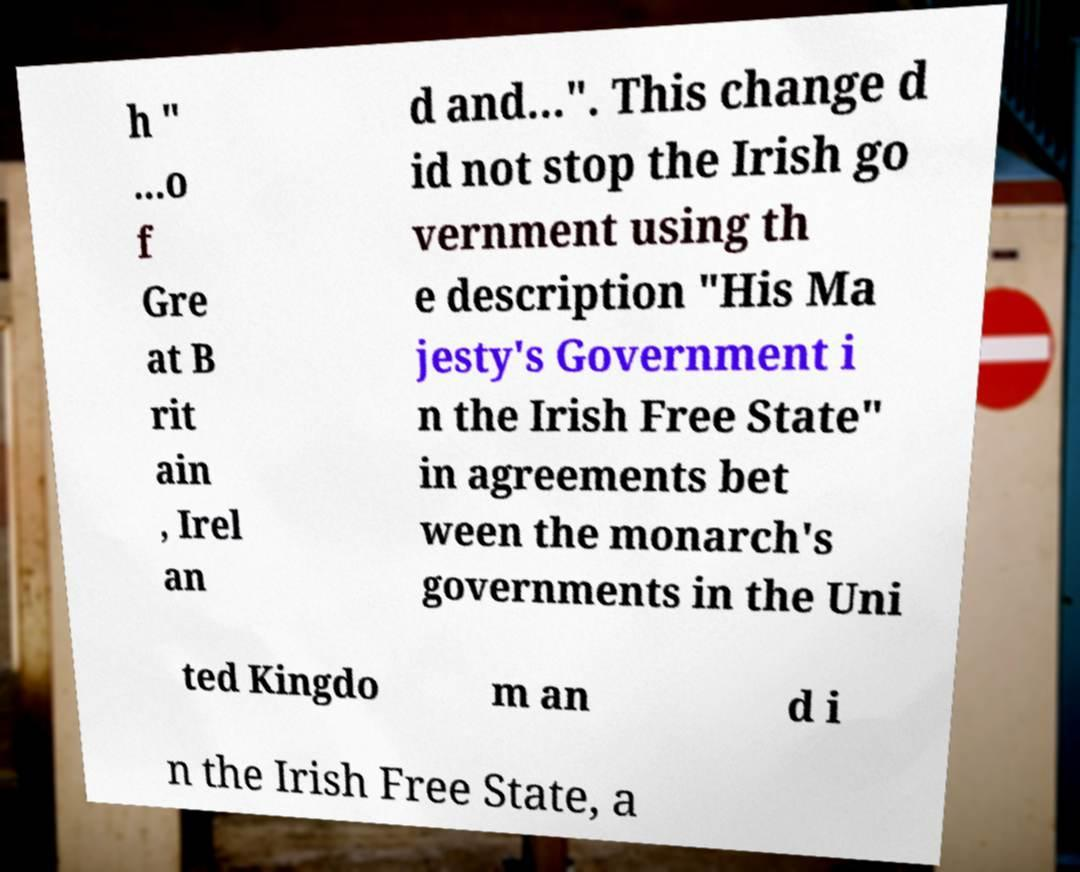For documentation purposes, I need the text within this image transcribed. Could you provide that? h " ...o f Gre at B rit ain , Irel an d and...". This change d id not stop the Irish go vernment using th e description "His Ma jesty's Government i n the Irish Free State" in agreements bet ween the monarch's governments in the Uni ted Kingdo m an d i n the Irish Free State, a 